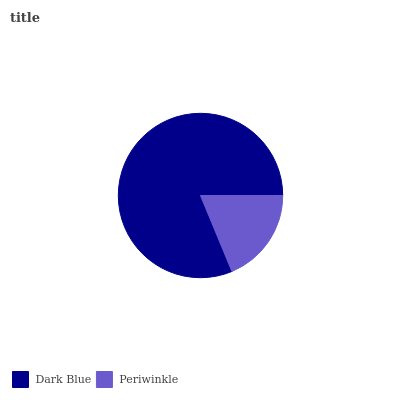Is Periwinkle the minimum?
Answer yes or no. Yes. Is Dark Blue the maximum?
Answer yes or no. Yes. Is Periwinkle the maximum?
Answer yes or no. No. Is Dark Blue greater than Periwinkle?
Answer yes or no. Yes. Is Periwinkle less than Dark Blue?
Answer yes or no. Yes. Is Periwinkle greater than Dark Blue?
Answer yes or no. No. Is Dark Blue less than Periwinkle?
Answer yes or no. No. Is Dark Blue the high median?
Answer yes or no. Yes. Is Periwinkle the low median?
Answer yes or no. Yes. Is Periwinkle the high median?
Answer yes or no. No. Is Dark Blue the low median?
Answer yes or no. No. 